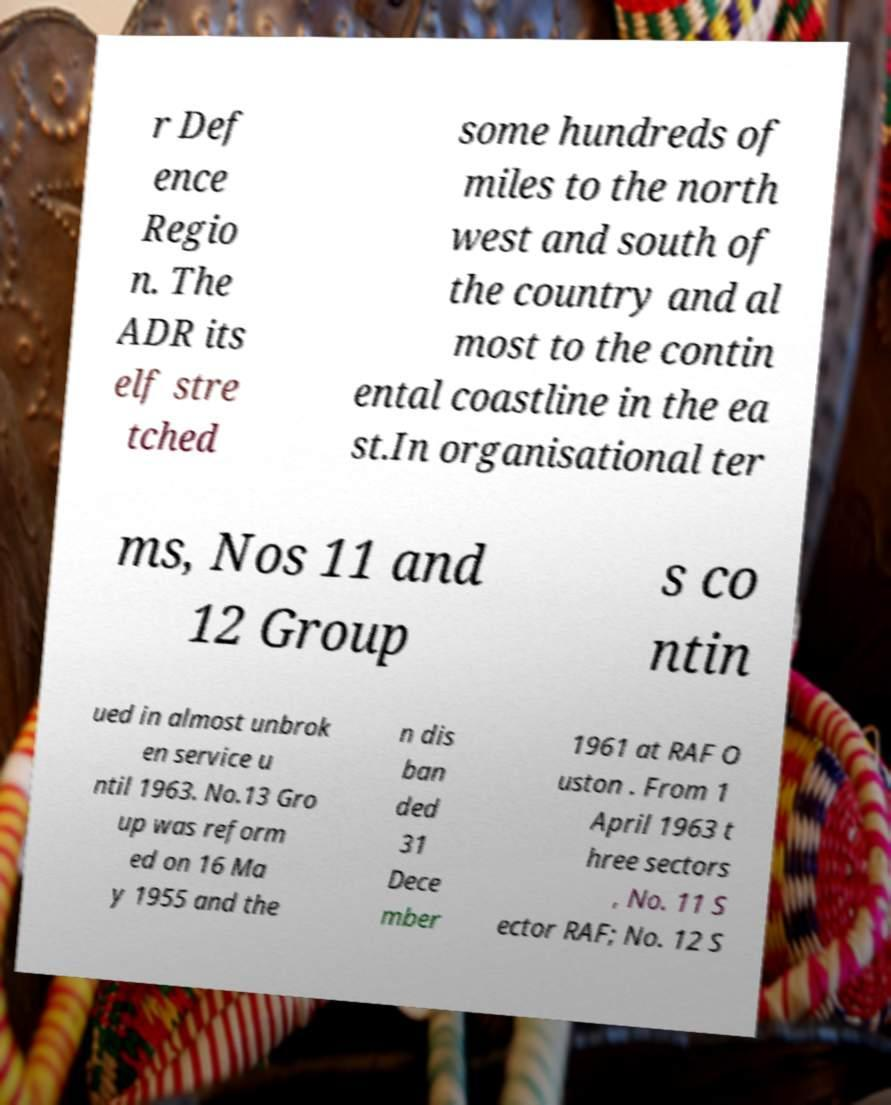Could you extract and type out the text from this image? r Def ence Regio n. The ADR its elf stre tched some hundreds of miles to the north west and south of the country and al most to the contin ental coastline in the ea st.In organisational ter ms, Nos 11 and 12 Group s co ntin ued in almost unbrok en service u ntil 1963. No.13 Gro up was reform ed on 16 Ma y 1955 and the n dis ban ded 31 Dece mber 1961 at RAF O uston . From 1 April 1963 t hree sectors , No. 11 S ector RAF; No. 12 S 